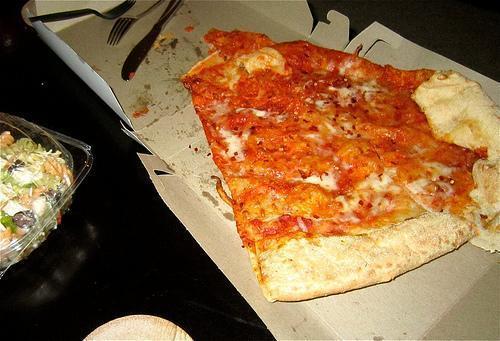How many slices of pizza?
Give a very brief answer. 1. How many forks are there?
Give a very brief answer. 2. 